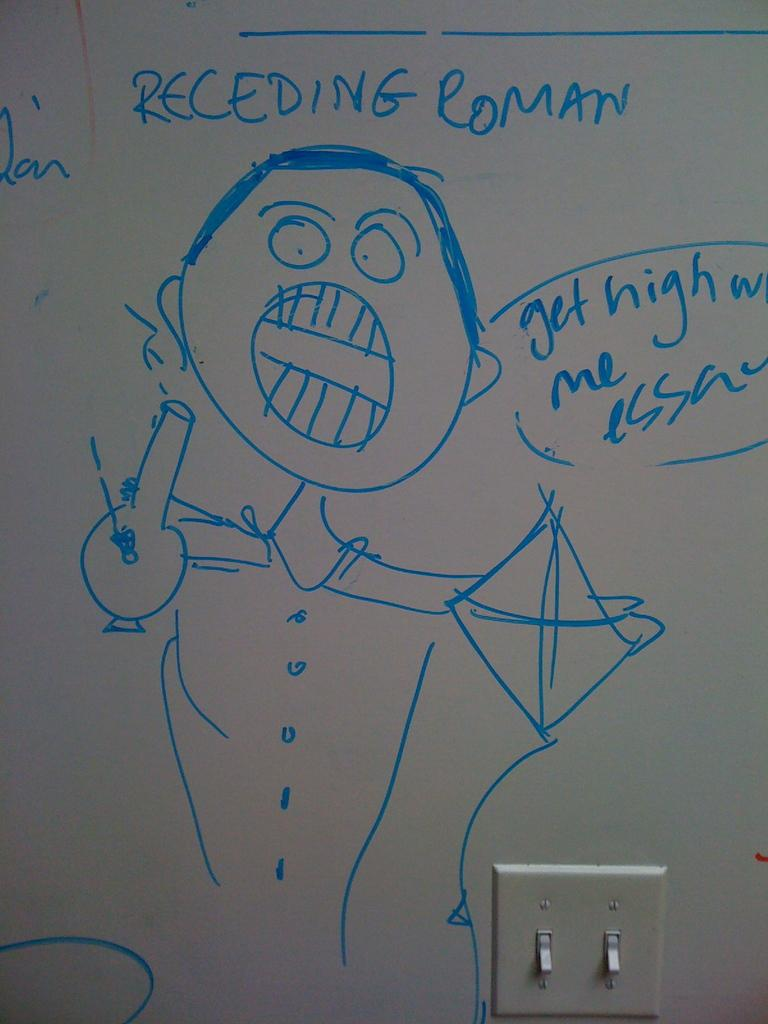<image>
Provide a brief description of the given image. a blue drawing on a whiteboard that says 'receding roman' 